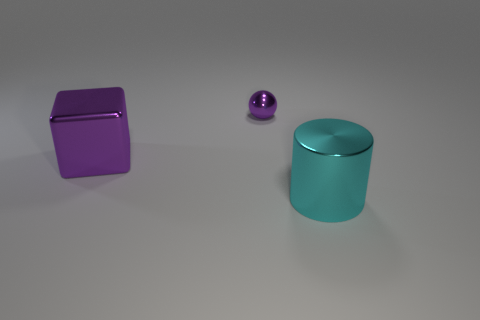Add 1 cyan things. How many objects exist? 4 Subtract all cubes. How many objects are left? 2 Subtract all small balls. Subtract all purple balls. How many objects are left? 1 Add 3 purple spheres. How many purple spheres are left? 4 Add 3 big cyan objects. How many big cyan objects exist? 4 Subtract 0 red cylinders. How many objects are left? 3 